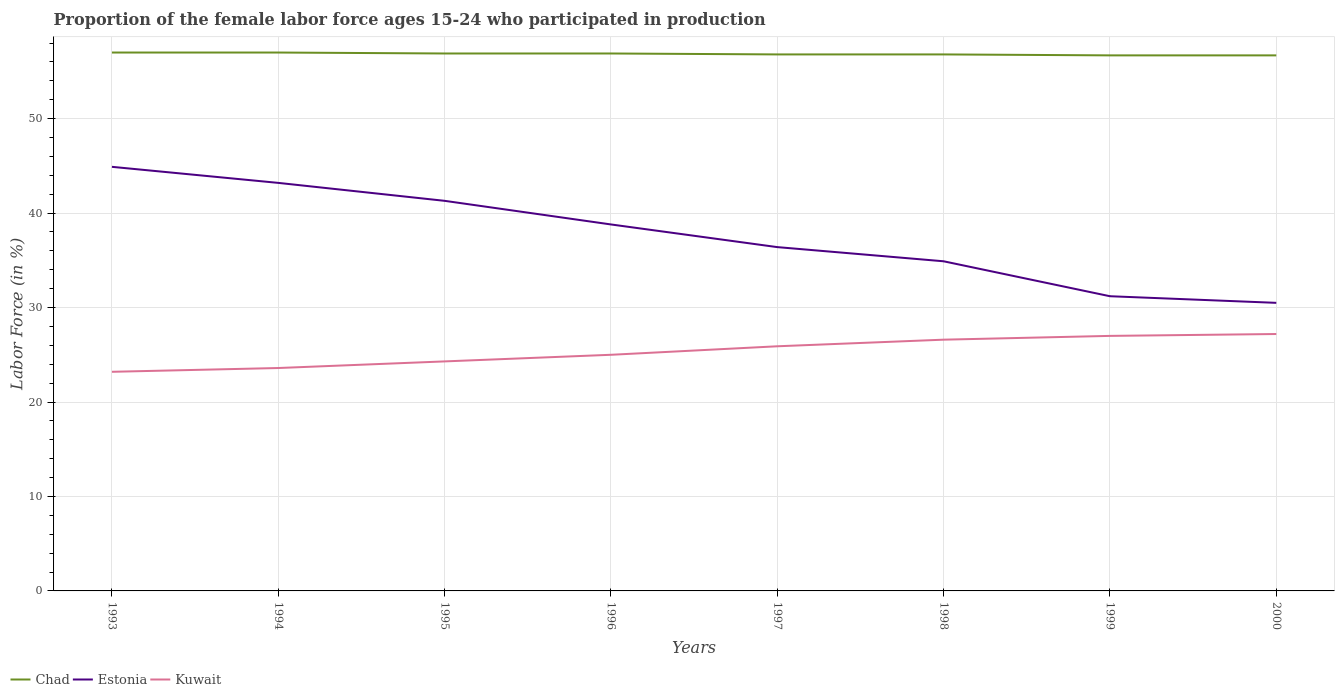Is the number of lines equal to the number of legend labels?
Provide a succinct answer. Yes. Across all years, what is the maximum proportion of the female labor force who participated in production in Estonia?
Ensure brevity in your answer.  30.5. What is the total proportion of the female labor force who participated in production in Estonia in the graph?
Provide a succinct answer. 8.3. What is the difference between the highest and the second highest proportion of the female labor force who participated in production in Chad?
Make the answer very short. 0.3. What is the difference between the highest and the lowest proportion of the female labor force who participated in production in Chad?
Your answer should be very brief. 4. How many years are there in the graph?
Provide a succinct answer. 8. Are the values on the major ticks of Y-axis written in scientific E-notation?
Your answer should be very brief. No. Does the graph contain any zero values?
Provide a succinct answer. No. Does the graph contain grids?
Make the answer very short. Yes. Where does the legend appear in the graph?
Keep it short and to the point. Bottom left. How many legend labels are there?
Offer a very short reply. 3. How are the legend labels stacked?
Provide a short and direct response. Horizontal. What is the title of the graph?
Provide a short and direct response. Proportion of the female labor force ages 15-24 who participated in production. What is the Labor Force (in %) of Chad in 1993?
Ensure brevity in your answer.  57. What is the Labor Force (in %) in Estonia in 1993?
Keep it short and to the point. 44.9. What is the Labor Force (in %) in Kuwait in 1993?
Give a very brief answer. 23.2. What is the Labor Force (in %) of Chad in 1994?
Your answer should be very brief. 57. What is the Labor Force (in %) in Estonia in 1994?
Offer a very short reply. 43.2. What is the Labor Force (in %) of Kuwait in 1994?
Provide a short and direct response. 23.6. What is the Labor Force (in %) of Chad in 1995?
Provide a short and direct response. 56.9. What is the Labor Force (in %) of Estonia in 1995?
Provide a succinct answer. 41.3. What is the Labor Force (in %) in Kuwait in 1995?
Provide a short and direct response. 24.3. What is the Labor Force (in %) of Chad in 1996?
Your answer should be very brief. 56.9. What is the Labor Force (in %) of Estonia in 1996?
Offer a very short reply. 38.8. What is the Labor Force (in %) in Chad in 1997?
Offer a terse response. 56.8. What is the Labor Force (in %) in Estonia in 1997?
Give a very brief answer. 36.4. What is the Labor Force (in %) in Kuwait in 1997?
Offer a very short reply. 25.9. What is the Labor Force (in %) of Chad in 1998?
Offer a very short reply. 56.8. What is the Labor Force (in %) of Estonia in 1998?
Provide a succinct answer. 34.9. What is the Labor Force (in %) in Kuwait in 1998?
Provide a short and direct response. 26.6. What is the Labor Force (in %) in Chad in 1999?
Provide a succinct answer. 56.7. What is the Labor Force (in %) in Estonia in 1999?
Ensure brevity in your answer.  31.2. What is the Labor Force (in %) of Kuwait in 1999?
Your answer should be compact. 27. What is the Labor Force (in %) of Chad in 2000?
Keep it short and to the point. 56.7. What is the Labor Force (in %) of Estonia in 2000?
Provide a succinct answer. 30.5. What is the Labor Force (in %) in Kuwait in 2000?
Your answer should be compact. 27.2. Across all years, what is the maximum Labor Force (in %) of Chad?
Give a very brief answer. 57. Across all years, what is the maximum Labor Force (in %) of Estonia?
Provide a succinct answer. 44.9. Across all years, what is the maximum Labor Force (in %) in Kuwait?
Give a very brief answer. 27.2. Across all years, what is the minimum Labor Force (in %) in Chad?
Your answer should be very brief. 56.7. Across all years, what is the minimum Labor Force (in %) in Estonia?
Your answer should be compact. 30.5. Across all years, what is the minimum Labor Force (in %) in Kuwait?
Your response must be concise. 23.2. What is the total Labor Force (in %) in Chad in the graph?
Provide a succinct answer. 454.8. What is the total Labor Force (in %) of Estonia in the graph?
Make the answer very short. 301.2. What is the total Labor Force (in %) of Kuwait in the graph?
Make the answer very short. 202.8. What is the difference between the Labor Force (in %) of Chad in 1993 and that in 1994?
Keep it short and to the point. 0. What is the difference between the Labor Force (in %) in Kuwait in 1993 and that in 1994?
Make the answer very short. -0.4. What is the difference between the Labor Force (in %) in Kuwait in 1993 and that in 1995?
Give a very brief answer. -1.1. What is the difference between the Labor Force (in %) of Kuwait in 1993 and that in 1996?
Provide a succinct answer. -1.8. What is the difference between the Labor Force (in %) of Estonia in 1993 and that in 1998?
Your response must be concise. 10. What is the difference between the Labor Force (in %) of Estonia in 1993 and that in 1999?
Offer a terse response. 13.7. What is the difference between the Labor Force (in %) of Kuwait in 1993 and that in 1999?
Keep it short and to the point. -3.8. What is the difference between the Labor Force (in %) in Chad in 1993 and that in 2000?
Provide a succinct answer. 0.3. What is the difference between the Labor Force (in %) of Estonia in 1993 and that in 2000?
Make the answer very short. 14.4. What is the difference between the Labor Force (in %) of Kuwait in 1993 and that in 2000?
Make the answer very short. -4. What is the difference between the Labor Force (in %) in Estonia in 1994 and that in 1995?
Keep it short and to the point. 1.9. What is the difference between the Labor Force (in %) in Estonia in 1994 and that in 1996?
Your answer should be very brief. 4.4. What is the difference between the Labor Force (in %) of Estonia in 1994 and that in 1997?
Provide a succinct answer. 6.8. What is the difference between the Labor Force (in %) of Kuwait in 1994 and that in 1998?
Your response must be concise. -3. What is the difference between the Labor Force (in %) of Chad in 1994 and that in 1999?
Offer a terse response. 0.3. What is the difference between the Labor Force (in %) of Estonia in 1994 and that in 1999?
Ensure brevity in your answer.  12. What is the difference between the Labor Force (in %) in Chad in 1994 and that in 2000?
Provide a succinct answer. 0.3. What is the difference between the Labor Force (in %) in Kuwait in 1994 and that in 2000?
Keep it short and to the point. -3.6. What is the difference between the Labor Force (in %) in Estonia in 1995 and that in 1996?
Offer a terse response. 2.5. What is the difference between the Labor Force (in %) of Kuwait in 1995 and that in 1996?
Give a very brief answer. -0.7. What is the difference between the Labor Force (in %) of Estonia in 1995 and that in 1997?
Offer a very short reply. 4.9. What is the difference between the Labor Force (in %) in Kuwait in 1995 and that in 1997?
Provide a short and direct response. -1.6. What is the difference between the Labor Force (in %) in Chad in 1995 and that in 1999?
Provide a short and direct response. 0.2. What is the difference between the Labor Force (in %) in Estonia in 1995 and that in 1999?
Your answer should be compact. 10.1. What is the difference between the Labor Force (in %) of Chad in 1996 and that in 1997?
Provide a succinct answer. 0.1. What is the difference between the Labor Force (in %) in Kuwait in 1996 and that in 1998?
Make the answer very short. -1.6. What is the difference between the Labor Force (in %) in Chad in 1996 and that in 1999?
Your answer should be very brief. 0.2. What is the difference between the Labor Force (in %) of Estonia in 1996 and that in 1999?
Offer a very short reply. 7.6. What is the difference between the Labor Force (in %) of Chad in 1996 and that in 2000?
Offer a terse response. 0.2. What is the difference between the Labor Force (in %) of Estonia in 1996 and that in 2000?
Your answer should be very brief. 8.3. What is the difference between the Labor Force (in %) in Kuwait in 1996 and that in 2000?
Provide a succinct answer. -2.2. What is the difference between the Labor Force (in %) of Kuwait in 1997 and that in 1998?
Ensure brevity in your answer.  -0.7. What is the difference between the Labor Force (in %) in Chad in 1997 and that in 1999?
Provide a succinct answer. 0.1. What is the difference between the Labor Force (in %) in Estonia in 1997 and that in 1999?
Your answer should be very brief. 5.2. What is the difference between the Labor Force (in %) of Kuwait in 1997 and that in 1999?
Keep it short and to the point. -1.1. What is the difference between the Labor Force (in %) in Estonia in 1997 and that in 2000?
Provide a short and direct response. 5.9. What is the difference between the Labor Force (in %) of Kuwait in 1998 and that in 1999?
Provide a succinct answer. -0.4. What is the difference between the Labor Force (in %) of Chad in 1998 and that in 2000?
Keep it short and to the point. 0.1. What is the difference between the Labor Force (in %) of Estonia in 1998 and that in 2000?
Your response must be concise. 4.4. What is the difference between the Labor Force (in %) in Kuwait in 1998 and that in 2000?
Offer a terse response. -0.6. What is the difference between the Labor Force (in %) of Chad in 1999 and that in 2000?
Provide a succinct answer. 0. What is the difference between the Labor Force (in %) of Estonia in 1999 and that in 2000?
Provide a short and direct response. 0.7. What is the difference between the Labor Force (in %) of Chad in 1993 and the Labor Force (in %) of Estonia in 1994?
Offer a very short reply. 13.8. What is the difference between the Labor Force (in %) in Chad in 1993 and the Labor Force (in %) in Kuwait in 1994?
Your answer should be very brief. 33.4. What is the difference between the Labor Force (in %) of Estonia in 1993 and the Labor Force (in %) of Kuwait in 1994?
Keep it short and to the point. 21.3. What is the difference between the Labor Force (in %) in Chad in 1993 and the Labor Force (in %) in Kuwait in 1995?
Ensure brevity in your answer.  32.7. What is the difference between the Labor Force (in %) in Estonia in 1993 and the Labor Force (in %) in Kuwait in 1995?
Ensure brevity in your answer.  20.6. What is the difference between the Labor Force (in %) in Chad in 1993 and the Labor Force (in %) in Kuwait in 1996?
Offer a terse response. 32. What is the difference between the Labor Force (in %) of Chad in 1993 and the Labor Force (in %) of Estonia in 1997?
Provide a succinct answer. 20.6. What is the difference between the Labor Force (in %) of Chad in 1993 and the Labor Force (in %) of Kuwait in 1997?
Your response must be concise. 31.1. What is the difference between the Labor Force (in %) in Chad in 1993 and the Labor Force (in %) in Estonia in 1998?
Keep it short and to the point. 22.1. What is the difference between the Labor Force (in %) of Chad in 1993 and the Labor Force (in %) of Kuwait in 1998?
Provide a short and direct response. 30.4. What is the difference between the Labor Force (in %) in Estonia in 1993 and the Labor Force (in %) in Kuwait in 1998?
Offer a terse response. 18.3. What is the difference between the Labor Force (in %) of Chad in 1993 and the Labor Force (in %) of Estonia in 1999?
Provide a succinct answer. 25.8. What is the difference between the Labor Force (in %) of Chad in 1993 and the Labor Force (in %) of Kuwait in 1999?
Your answer should be compact. 30. What is the difference between the Labor Force (in %) in Estonia in 1993 and the Labor Force (in %) in Kuwait in 1999?
Your answer should be compact. 17.9. What is the difference between the Labor Force (in %) of Chad in 1993 and the Labor Force (in %) of Kuwait in 2000?
Your answer should be compact. 29.8. What is the difference between the Labor Force (in %) in Chad in 1994 and the Labor Force (in %) in Kuwait in 1995?
Make the answer very short. 32.7. What is the difference between the Labor Force (in %) in Chad in 1994 and the Labor Force (in %) in Estonia in 1996?
Your answer should be compact. 18.2. What is the difference between the Labor Force (in %) in Chad in 1994 and the Labor Force (in %) in Kuwait in 1996?
Provide a succinct answer. 32. What is the difference between the Labor Force (in %) of Chad in 1994 and the Labor Force (in %) of Estonia in 1997?
Your answer should be compact. 20.6. What is the difference between the Labor Force (in %) of Chad in 1994 and the Labor Force (in %) of Kuwait in 1997?
Your answer should be very brief. 31.1. What is the difference between the Labor Force (in %) of Estonia in 1994 and the Labor Force (in %) of Kuwait in 1997?
Offer a terse response. 17.3. What is the difference between the Labor Force (in %) in Chad in 1994 and the Labor Force (in %) in Estonia in 1998?
Keep it short and to the point. 22.1. What is the difference between the Labor Force (in %) in Chad in 1994 and the Labor Force (in %) in Kuwait in 1998?
Provide a succinct answer. 30.4. What is the difference between the Labor Force (in %) in Estonia in 1994 and the Labor Force (in %) in Kuwait in 1998?
Your answer should be compact. 16.6. What is the difference between the Labor Force (in %) in Chad in 1994 and the Labor Force (in %) in Estonia in 1999?
Offer a very short reply. 25.8. What is the difference between the Labor Force (in %) in Chad in 1994 and the Labor Force (in %) in Kuwait in 1999?
Make the answer very short. 30. What is the difference between the Labor Force (in %) in Chad in 1994 and the Labor Force (in %) in Estonia in 2000?
Your response must be concise. 26.5. What is the difference between the Labor Force (in %) in Chad in 1994 and the Labor Force (in %) in Kuwait in 2000?
Your response must be concise. 29.8. What is the difference between the Labor Force (in %) of Estonia in 1994 and the Labor Force (in %) of Kuwait in 2000?
Ensure brevity in your answer.  16. What is the difference between the Labor Force (in %) of Chad in 1995 and the Labor Force (in %) of Estonia in 1996?
Offer a terse response. 18.1. What is the difference between the Labor Force (in %) in Chad in 1995 and the Labor Force (in %) in Kuwait in 1996?
Ensure brevity in your answer.  31.9. What is the difference between the Labor Force (in %) of Estonia in 1995 and the Labor Force (in %) of Kuwait in 1997?
Your answer should be compact. 15.4. What is the difference between the Labor Force (in %) of Chad in 1995 and the Labor Force (in %) of Estonia in 1998?
Give a very brief answer. 22. What is the difference between the Labor Force (in %) of Chad in 1995 and the Labor Force (in %) of Kuwait in 1998?
Your answer should be very brief. 30.3. What is the difference between the Labor Force (in %) in Chad in 1995 and the Labor Force (in %) in Estonia in 1999?
Ensure brevity in your answer.  25.7. What is the difference between the Labor Force (in %) of Chad in 1995 and the Labor Force (in %) of Kuwait in 1999?
Offer a very short reply. 29.9. What is the difference between the Labor Force (in %) in Estonia in 1995 and the Labor Force (in %) in Kuwait in 1999?
Keep it short and to the point. 14.3. What is the difference between the Labor Force (in %) of Chad in 1995 and the Labor Force (in %) of Estonia in 2000?
Ensure brevity in your answer.  26.4. What is the difference between the Labor Force (in %) in Chad in 1995 and the Labor Force (in %) in Kuwait in 2000?
Ensure brevity in your answer.  29.7. What is the difference between the Labor Force (in %) of Estonia in 1995 and the Labor Force (in %) of Kuwait in 2000?
Ensure brevity in your answer.  14.1. What is the difference between the Labor Force (in %) in Chad in 1996 and the Labor Force (in %) in Estonia in 1997?
Your answer should be compact. 20.5. What is the difference between the Labor Force (in %) in Estonia in 1996 and the Labor Force (in %) in Kuwait in 1997?
Ensure brevity in your answer.  12.9. What is the difference between the Labor Force (in %) of Chad in 1996 and the Labor Force (in %) of Estonia in 1998?
Your response must be concise. 22. What is the difference between the Labor Force (in %) in Chad in 1996 and the Labor Force (in %) in Kuwait in 1998?
Your response must be concise. 30.3. What is the difference between the Labor Force (in %) in Estonia in 1996 and the Labor Force (in %) in Kuwait in 1998?
Keep it short and to the point. 12.2. What is the difference between the Labor Force (in %) in Chad in 1996 and the Labor Force (in %) in Estonia in 1999?
Offer a very short reply. 25.7. What is the difference between the Labor Force (in %) in Chad in 1996 and the Labor Force (in %) in Kuwait in 1999?
Give a very brief answer. 29.9. What is the difference between the Labor Force (in %) in Estonia in 1996 and the Labor Force (in %) in Kuwait in 1999?
Keep it short and to the point. 11.8. What is the difference between the Labor Force (in %) in Chad in 1996 and the Labor Force (in %) in Estonia in 2000?
Give a very brief answer. 26.4. What is the difference between the Labor Force (in %) in Chad in 1996 and the Labor Force (in %) in Kuwait in 2000?
Give a very brief answer. 29.7. What is the difference between the Labor Force (in %) of Estonia in 1996 and the Labor Force (in %) of Kuwait in 2000?
Ensure brevity in your answer.  11.6. What is the difference between the Labor Force (in %) of Chad in 1997 and the Labor Force (in %) of Estonia in 1998?
Offer a terse response. 21.9. What is the difference between the Labor Force (in %) of Chad in 1997 and the Labor Force (in %) of Kuwait in 1998?
Give a very brief answer. 30.2. What is the difference between the Labor Force (in %) in Estonia in 1997 and the Labor Force (in %) in Kuwait in 1998?
Provide a succinct answer. 9.8. What is the difference between the Labor Force (in %) in Chad in 1997 and the Labor Force (in %) in Estonia in 1999?
Provide a short and direct response. 25.6. What is the difference between the Labor Force (in %) in Chad in 1997 and the Labor Force (in %) in Kuwait in 1999?
Provide a succinct answer. 29.8. What is the difference between the Labor Force (in %) in Estonia in 1997 and the Labor Force (in %) in Kuwait in 1999?
Your answer should be very brief. 9.4. What is the difference between the Labor Force (in %) in Chad in 1997 and the Labor Force (in %) in Estonia in 2000?
Your answer should be very brief. 26.3. What is the difference between the Labor Force (in %) in Chad in 1997 and the Labor Force (in %) in Kuwait in 2000?
Your answer should be very brief. 29.6. What is the difference between the Labor Force (in %) in Chad in 1998 and the Labor Force (in %) in Estonia in 1999?
Make the answer very short. 25.6. What is the difference between the Labor Force (in %) of Chad in 1998 and the Labor Force (in %) of Kuwait in 1999?
Provide a succinct answer. 29.8. What is the difference between the Labor Force (in %) of Estonia in 1998 and the Labor Force (in %) of Kuwait in 1999?
Give a very brief answer. 7.9. What is the difference between the Labor Force (in %) in Chad in 1998 and the Labor Force (in %) in Estonia in 2000?
Your response must be concise. 26.3. What is the difference between the Labor Force (in %) in Chad in 1998 and the Labor Force (in %) in Kuwait in 2000?
Your response must be concise. 29.6. What is the difference between the Labor Force (in %) in Estonia in 1998 and the Labor Force (in %) in Kuwait in 2000?
Keep it short and to the point. 7.7. What is the difference between the Labor Force (in %) of Chad in 1999 and the Labor Force (in %) of Estonia in 2000?
Your answer should be very brief. 26.2. What is the difference between the Labor Force (in %) of Chad in 1999 and the Labor Force (in %) of Kuwait in 2000?
Your answer should be compact. 29.5. What is the difference between the Labor Force (in %) in Estonia in 1999 and the Labor Force (in %) in Kuwait in 2000?
Keep it short and to the point. 4. What is the average Labor Force (in %) in Chad per year?
Provide a succinct answer. 56.85. What is the average Labor Force (in %) of Estonia per year?
Offer a terse response. 37.65. What is the average Labor Force (in %) of Kuwait per year?
Your answer should be very brief. 25.35. In the year 1993, what is the difference between the Labor Force (in %) in Chad and Labor Force (in %) in Estonia?
Provide a succinct answer. 12.1. In the year 1993, what is the difference between the Labor Force (in %) in Chad and Labor Force (in %) in Kuwait?
Provide a succinct answer. 33.8. In the year 1993, what is the difference between the Labor Force (in %) of Estonia and Labor Force (in %) of Kuwait?
Your answer should be very brief. 21.7. In the year 1994, what is the difference between the Labor Force (in %) of Chad and Labor Force (in %) of Kuwait?
Provide a succinct answer. 33.4. In the year 1994, what is the difference between the Labor Force (in %) in Estonia and Labor Force (in %) in Kuwait?
Offer a very short reply. 19.6. In the year 1995, what is the difference between the Labor Force (in %) of Chad and Labor Force (in %) of Kuwait?
Make the answer very short. 32.6. In the year 1995, what is the difference between the Labor Force (in %) of Estonia and Labor Force (in %) of Kuwait?
Provide a short and direct response. 17. In the year 1996, what is the difference between the Labor Force (in %) of Chad and Labor Force (in %) of Kuwait?
Give a very brief answer. 31.9. In the year 1997, what is the difference between the Labor Force (in %) in Chad and Labor Force (in %) in Estonia?
Your answer should be compact. 20.4. In the year 1997, what is the difference between the Labor Force (in %) of Chad and Labor Force (in %) of Kuwait?
Your answer should be very brief. 30.9. In the year 1998, what is the difference between the Labor Force (in %) of Chad and Labor Force (in %) of Estonia?
Provide a short and direct response. 21.9. In the year 1998, what is the difference between the Labor Force (in %) in Chad and Labor Force (in %) in Kuwait?
Offer a terse response. 30.2. In the year 1998, what is the difference between the Labor Force (in %) of Estonia and Labor Force (in %) of Kuwait?
Your answer should be very brief. 8.3. In the year 1999, what is the difference between the Labor Force (in %) of Chad and Labor Force (in %) of Estonia?
Give a very brief answer. 25.5. In the year 1999, what is the difference between the Labor Force (in %) of Chad and Labor Force (in %) of Kuwait?
Your response must be concise. 29.7. In the year 1999, what is the difference between the Labor Force (in %) of Estonia and Labor Force (in %) of Kuwait?
Ensure brevity in your answer.  4.2. In the year 2000, what is the difference between the Labor Force (in %) of Chad and Labor Force (in %) of Estonia?
Keep it short and to the point. 26.2. In the year 2000, what is the difference between the Labor Force (in %) in Chad and Labor Force (in %) in Kuwait?
Make the answer very short. 29.5. In the year 2000, what is the difference between the Labor Force (in %) of Estonia and Labor Force (in %) of Kuwait?
Your answer should be compact. 3.3. What is the ratio of the Labor Force (in %) of Estonia in 1993 to that in 1994?
Make the answer very short. 1.04. What is the ratio of the Labor Force (in %) in Kuwait in 1993 to that in 1994?
Make the answer very short. 0.98. What is the ratio of the Labor Force (in %) of Estonia in 1993 to that in 1995?
Give a very brief answer. 1.09. What is the ratio of the Labor Force (in %) in Kuwait in 1993 to that in 1995?
Keep it short and to the point. 0.95. What is the ratio of the Labor Force (in %) in Estonia in 1993 to that in 1996?
Your response must be concise. 1.16. What is the ratio of the Labor Force (in %) in Kuwait in 1993 to that in 1996?
Your response must be concise. 0.93. What is the ratio of the Labor Force (in %) of Estonia in 1993 to that in 1997?
Keep it short and to the point. 1.23. What is the ratio of the Labor Force (in %) of Kuwait in 1993 to that in 1997?
Your answer should be very brief. 0.9. What is the ratio of the Labor Force (in %) of Chad in 1993 to that in 1998?
Give a very brief answer. 1. What is the ratio of the Labor Force (in %) in Estonia in 1993 to that in 1998?
Offer a terse response. 1.29. What is the ratio of the Labor Force (in %) of Kuwait in 1993 to that in 1998?
Provide a short and direct response. 0.87. What is the ratio of the Labor Force (in %) in Estonia in 1993 to that in 1999?
Provide a succinct answer. 1.44. What is the ratio of the Labor Force (in %) in Kuwait in 1993 to that in 1999?
Your response must be concise. 0.86. What is the ratio of the Labor Force (in %) of Chad in 1993 to that in 2000?
Offer a terse response. 1.01. What is the ratio of the Labor Force (in %) in Estonia in 1993 to that in 2000?
Provide a short and direct response. 1.47. What is the ratio of the Labor Force (in %) in Kuwait in 1993 to that in 2000?
Your response must be concise. 0.85. What is the ratio of the Labor Force (in %) of Chad in 1994 to that in 1995?
Your answer should be compact. 1. What is the ratio of the Labor Force (in %) of Estonia in 1994 to that in 1995?
Offer a terse response. 1.05. What is the ratio of the Labor Force (in %) of Kuwait in 1994 to that in 1995?
Give a very brief answer. 0.97. What is the ratio of the Labor Force (in %) of Chad in 1994 to that in 1996?
Your answer should be very brief. 1. What is the ratio of the Labor Force (in %) of Estonia in 1994 to that in 1996?
Offer a terse response. 1.11. What is the ratio of the Labor Force (in %) of Kuwait in 1994 to that in 1996?
Give a very brief answer. 0.94. What is the ratio of the Labor Force (in %) of Estonia in 1994 to that in 1997?
Make the answer very short. 1.19. What is the ratio of the Labor Force (in %) of Kuwait in 1994 to that in 1997?
Provide a succinct answer. 0.91. What is the ratio of the Labor Force (in %) in Chad in 1994 to that in 1998?
Make the answer very short. 1. What is the ratio of the Labor Force (in %) of Estonia in 1994 to that in 1998?
Your response must be concise. 1.24. What is the ratio of the Labor Force (in %) in Kuwait in 1994 to that in 1998?
Offer a terse response. 0.89. What is the ratio of the Labor Force (in %) of Chad in 1994 to that in 1999?
Your answer should be very brief. 1.01. What is the ratio of the Labor Force (in %) in Estonia in 1994 to that in 1999?
Offer a very short reply. 1.38. What is the ratio of the Labor Force (in %) in Kuwait in 1994 to that in 1999?
Offer a very short reply. 0.87. What is the ratio of the Labor Force (in %) of Chad in 1994 to that in 2000?
Your answer should be compact. 1.01. What is the ratio of the Labor Force (in %) of Estonia in 1994 to that in 2000?
Give a very brief answer. 1.42. What is the ratio of the Labor Force (in %) in Kuwait in 1994 to that in 2000?
Make the answer very short. 0.87. What is the ratio of the Labor Force (in %) of Chad in 1995 to that in 1996?
Your answer should be very brief. 1. What is the ratio of the Labor Force (in %) in Estonia in 1995 to that in 1996?
Keep it short and to the point. 1.06. What is the ratio of the Labor Force (in %) in Kuwait in 1995 to that in 1996?
Keep it short and to the point. 0.97. What is the ratio of the Labor Force (in %) of Estonia in 1995 to that in 1997?
Provide a short and direct response. 1.13. What is the ratio of the Labor Force (in %) in Kuwait in 1995 to that in 1997?
Provide a succinct answer. 0.94. What is the ratio of the Labor Force (in %) of Estonia in 1995 to that in 1998?
Provide a short and direct response. 1.18. What is the ratio of the Labor Force (in %) of Kuwait in 1995 to that in 1998?
Offer a terse response. 0.91. What is the ratio of the Labor Force (in %) in Estonia in 1995 to that in 1999?
Your answer should be very brief. 1.32. What is the ratio of the Labor Force (in %) of Kuwait in 1995 to that in 1999?
Ensure brevity in your answer.  0.9. What is the ratio of the Labor Force (in %) in Estonia in 1995 to that in 2000?
Offer a terse response. 1.35. What is the ratio of the Labor Force (in %) in Kuwait in 1995 to that in 2000?
Give a very brief answer. 0.89. What is the ratio of the Labor Force (in %) of Estonia in 1996 to that in 1997?
Provide a succinct answer. 1.07. What is the ratio of the Labor Force (in %) of Kuwait in 1996 to that in 1997?
Make the answer very short. 0.97. What is the ratio of the Labor Force (in %) of Chad in 1996 to that in 1998?
Your answer should be very brief. 1. What is the ratio of the Labor Force (in %) of Estonia in 1996 to that in 1998?
Give a very brief answer. 1.11. What is the ratio of the Labor Force (in %) in Kuwait in 1996 to that in 1998?
Give a very brief answer. 0.94. What is the ratio of the Labor Force (in %) in Estonia in 1996 to that in 1999?
Provide a short and direct response. 1.24. What is the ratio of the Labor Force (in %) in Kuwait in 1996 to that in 1999?
Provide a succinct answer. 0.93. What is the ratio of the Labor Force (in %) in Chad in 1996 to that in 2000?
Provide a short and direct response. 1. What is the ratio of the Labor Force (in %) in Estonia in 1996 to that in 2000?
Provide a short and direct response. 1.27. What is the ratio of the Labor Force (in %) of Kuwait in 1996 to that in 2000?
Ensure brevity in your answer.  0.92. What is the ratio of the Labor Force (in %) of Chad in 1997 to that in 1998?
Provide a succinct answer. 1. What is the ratio of the Labor Force (in %) in Estonia in 1997 to that in 1998?
Provide a short and direct response. 1.04. What is the ratio of the Labor Force (in %) of Kuwait in 1997 to that in 1998?
Make the answer very short. 0.97. What is the ratio of the Labor Force (in %) in Estonia in 1997 to that in 1999?
Ensure brevity in your answer.  1.17. What is the ratio of the Labor Force (in %) of Kuwait in 1997 to that in 1999?
Your response must be concise. 0.96. What is the ratio of the Labor Force (in %) of Chad in 1997 to that in 2000?
Give a very brief answer. 1. What is the ratio of the Labor Force (in %) in Estonia in 1997 to that in 2000?
Ensure brevity in your answer.  1.19. What is the ratio of the Labor Force (in %) of Kuwait in 1997 to that in 2000?
Keep it short and to the point. 0.95. What is the ratio of the Labor Force (in %) of Estonia in 1998 to that in 1999?
Offer a very short reply. 1.12. What is the ratio of the Labor Force (in %) of Kuwait in 1998 to that in 1999?
Your answer should be very brief. 0.99. What is the ratio of the Labor Force (in %) of Chad in 1998 to that in 2000?
Your response must be concise. 1. What is the ratio of the Labor Force (in %) of Estonia in 1998 to that in 2000?
Provide a short and direct response. 1.14. What is the ratio of the Labor Force (in %) of Kuwait in 1998 to that in 2000?
Provide a succinct answer. 0.98. What is the ratio of the Labor Force (in %) of Kuwait in 1999 to that in 2000?
Give a very brief answer. 0.99. What is the difference between the highest and the second highest Labor Force (in %) of Estonia?
Give a very brief answer. 1.7. What is the difference between the highest and the lowest Labor Force (in %) in Estonia?
Give a very brief answer. 14.4. What is the difference between the highest and the lowest Labor Force (in %) in Kuwait?
Ensure brevity in your answer.  4. 